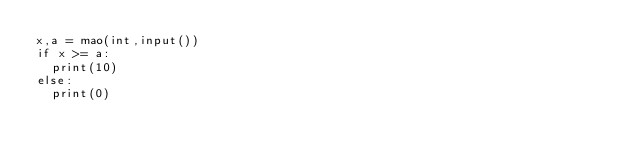<code> <loc_0><loc_0><loc_500><loc_500><_Python_>x,a = mao(int,input())
if x >= a:
  print(10)
else:
  print(0)</code> 